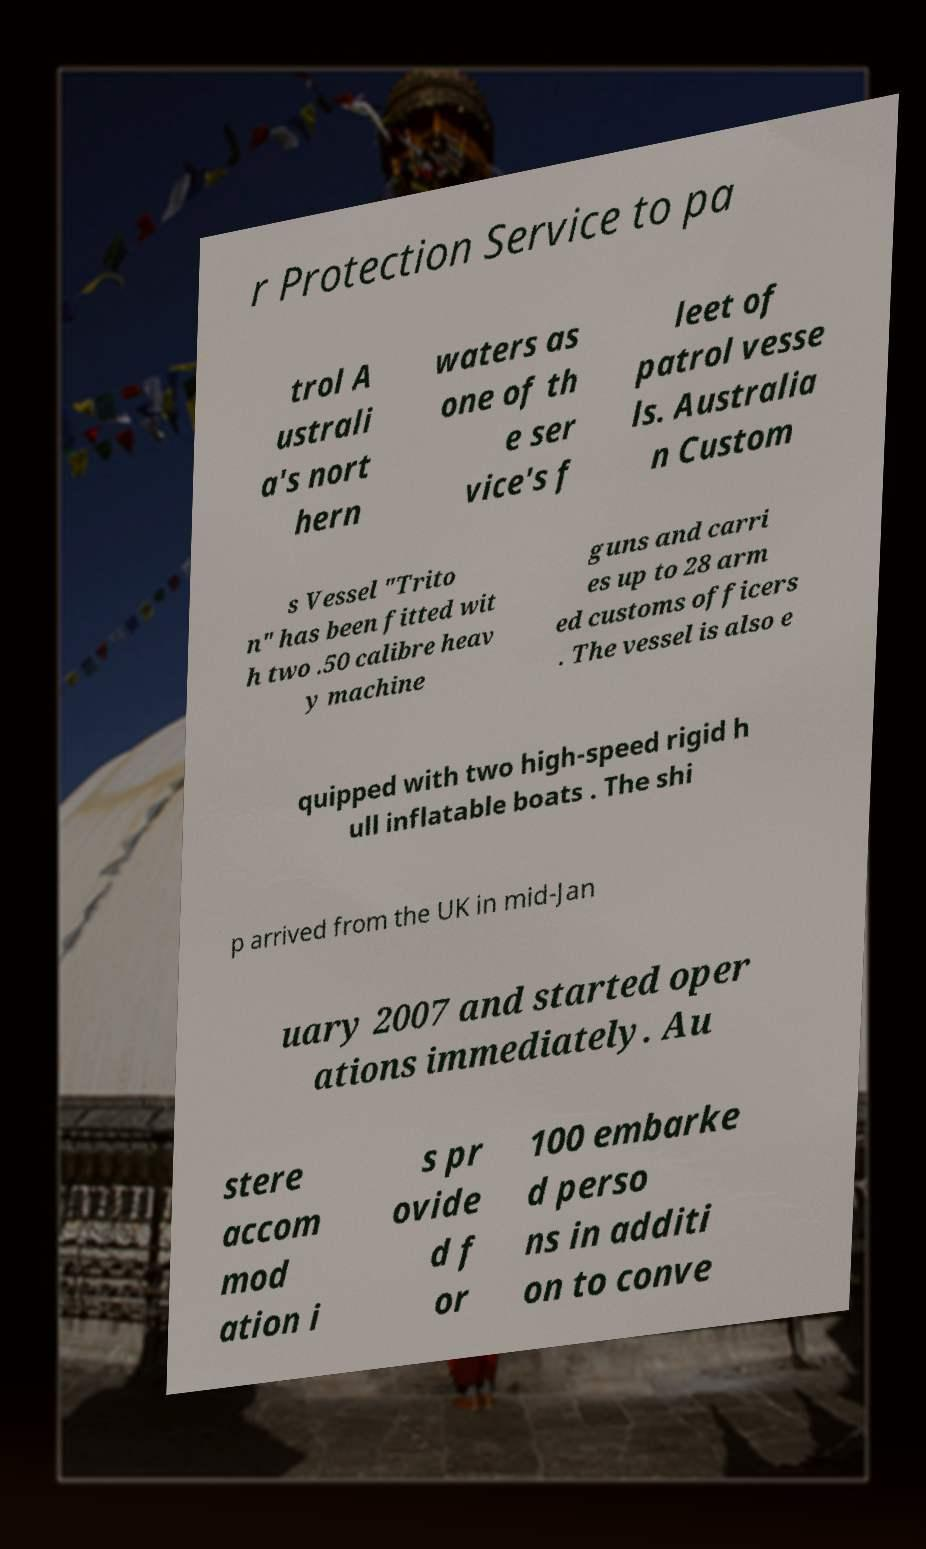Could you assist in decoding the text presented in this image and type it out clearly? r Protection Service to pa trol A ustrali a's nort hern waters as one of th e ser vice's f leet of patrol vesse ls. Australia n Custom s Vessel "Trito n" has been fitted wit h two .50 calibre heav y machine guns and carri es up to 28 arm ed customs officers . The vessel is also e quipped with two high-speed rigid h ull inflatable boats . The shi p arrived from the UK in mid-Jan uary 2007 and started oper ations immediately. Au stere accom mod ation i s pr ovide d f or 100 embarke d perso ns in additi on to conve 